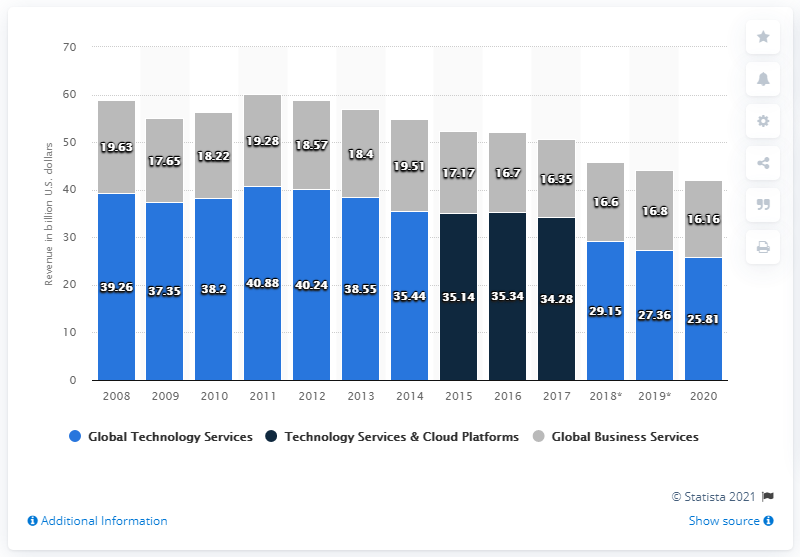Point out several critical features in this image. In 2020, the revenue of IBM's Global Technology Services segment was 25.81 billion USD. 